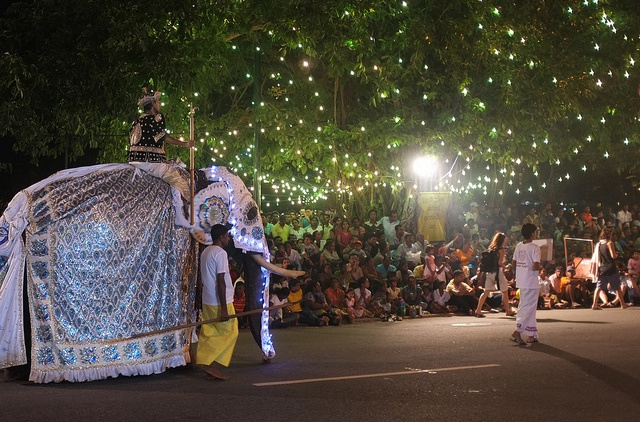Describe the objects in this image and their specific colors. I can see elephant in black, darkgray, and gray tones, people in black, maroon, and gray tones, people in black, darkgray, and olive tones, people in black, darkgray, gray, and maroon tones, and people in black, maroon, and brown tones in this image. 